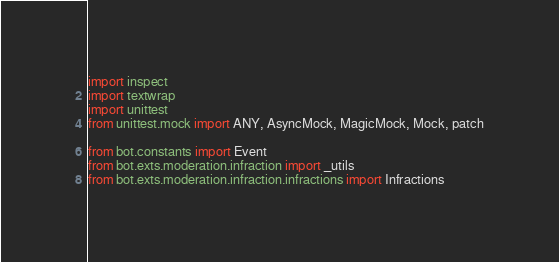<code> <loc_0><loc_0><loc_500><loc_500><_Python_>import inspect
import textwrap
import unittest
from unittest.mock import ANY, AsyncMock, MagicMock, Mock, patch

from bot.constants import Event
from bot.exts.moderation.infraction import _utils
from bot.exts.moderation.infraction.infractions import Infractions</code> 